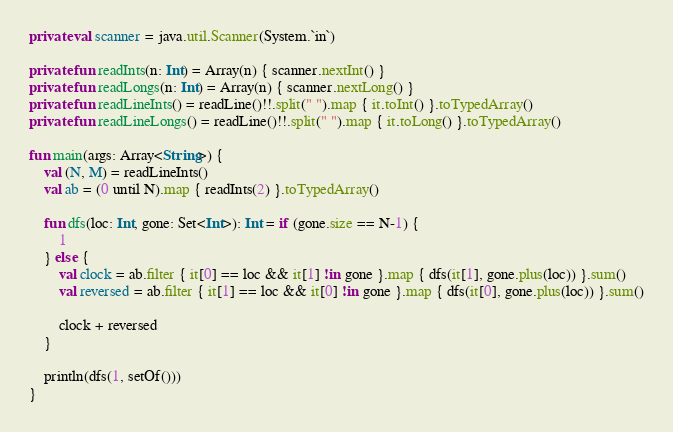Convert code to text. <code><loc_0><loc_0><loc_500><loc_500><_Kotlin_>private val scanner = java.util.Scanner(System.`in`)

private fun readInts(n: Int) = Array(n) { scanner.nextInt() }
private fun readLongs(n: Int) = Array(n) { scanner.nextLong() }
private fun readLineInts() = readLine()!!.split(" ").map { it.toInt() }.toTypedArray()
private fun readLineLongs() = readLine()!!.split(" ").map { it.toLong() }.toTypedArray()

fun main(args: Array<String>) {
    val (N, M) = readLineInts()
    val ab = (0 until N).map { readInts(2) }.toTypedArray()

    fun dfs(loc: Int, gone: Set<Int>): Int = if (gone.size == N-1) {
        1
    } else {
        val clock = ab.filter { it[0] == loc && it[1] !in gone }.map { dfs(it[1], gone.plus(loc)) }.sum()
        val reversed = ab.filter { it[1] == loc && it[0] !in gone }.map { dfs(it[0], gone.plus(loc)) }.sum()

        clock + reversed
    }

    println(dfs(1, setOf()))
}</code> 